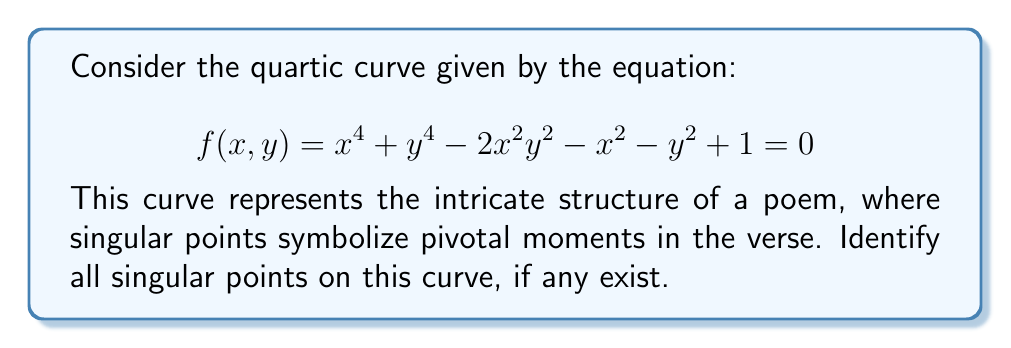What is the answer to this math problem? To find the singular points of the curve, we need to follow these steps:

1) A point $(x,y)$ is singular if it satisfies the curve equation and both partial derivatives are zero at that point. Let's calculate the partial derivatives:

   $$\frac{\partial f}{\partial x} = 4x^3 - 4xy^2 - 2x$$
   $$\frac{\partial f}{\partial y} = 4y^3 - 4x^2y - 2y$$

2) Set both partial derivatives to zero:

   $$4x^3 - 4xy^2 - 2x = 0$$
   $$4y^3 - 4x^2y - 2y = 0$$

3) Factor out common terms:

   $$2x(2x^2 - 2y^2 - 1) = 0$$
   $$2y(2y^2 - 2x^2 - 1) = 0$$

4) From these equations, we can see that $(0,0)$ is a solution. Let's check if it satisfies the original equation:

   $$f(0,0) = 0^4 + 0^4 - 2(0^2)(0^2) - 0^2 - 0^2 + 1 = 1$$

   Since $f(0,0) \neq 0$, $(0,0)$ is not on the curve and thus not a singular point.

5) For non-zero $x$ and $y$, we must have:

   $$2x^2 - 2y^2 - 1 = 0$$
   $$2y^2 - 2x^2 - 1 = 0$$

6) Adding these equations gives $-2 = 0$, which is impossible. Therefore, there are no solutions for non-zero $x$ and $y$.

7) We conclude that this quartic curve has no singular points.
Answer: The curve has no singular points. 